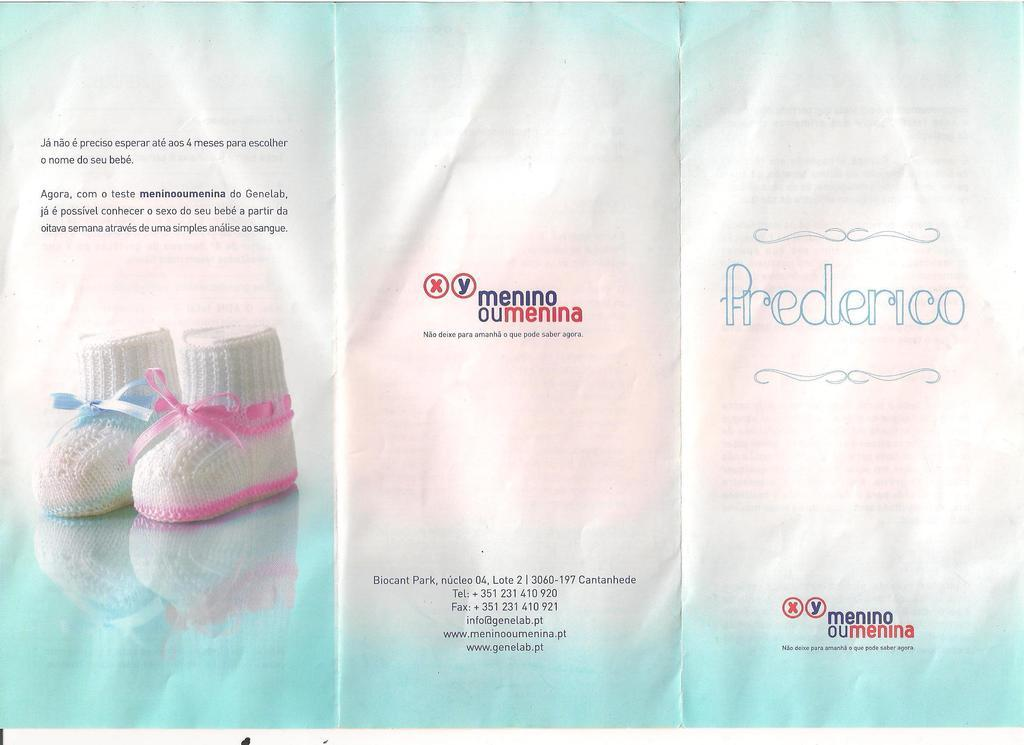What is the main subject in the center of the image? There is a poster in the center of the image. What is depicted on the poster? The poster features two colorful shoes. Is there any text on the poster? Yes, there is text on the poster. Can you tell me how many horses are depicted on the poster? There are no horses depicted on the poster; it features two colorful shoes. Is there a recess area visible in the image? There is no recess area visible in the image; it only features a poster with shoes and text. 